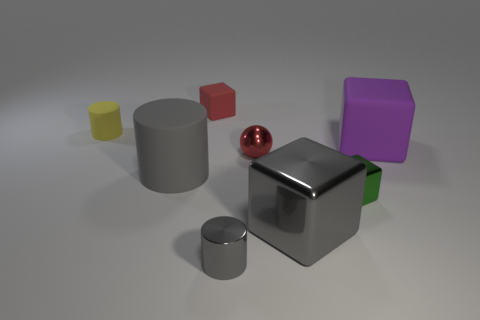What number of blocks are both right of the big gray metallic thing and behind the purple rubber cube?
Make the answer very short. 0. What is the tiny yellow cylinder made of?
Offer a very short reply. Rubber. Are there an equal number of small things to the left of the large gray shiny block and gray objects?
Provide a succinct answer. No. How many large purple things are the same shape as the small red shiny thing?
Offer a terse response. 0. Do the big purple thing and the small yellow object have the same shape?
Keep it short and to the point. No. How many things are either objects behind the large purple matte thing or large blue balls?
Your response must be concise. 2. There is a big gray object left of the tiny rubber thing on the right side of the matte cylinder that is in front of the tiny matte cylinder; what is its shape?
Your answer should be compact. Cylinder. What shape is the tiny green object that is made of the same material as the small red sphere?
Provide a short and direct response. Cube. How big is the purple matte object?
Offer a very short reply. Large. Is the size of the metallic ball the same as the green metal cube?
Keep it short and to the point. Yes. 